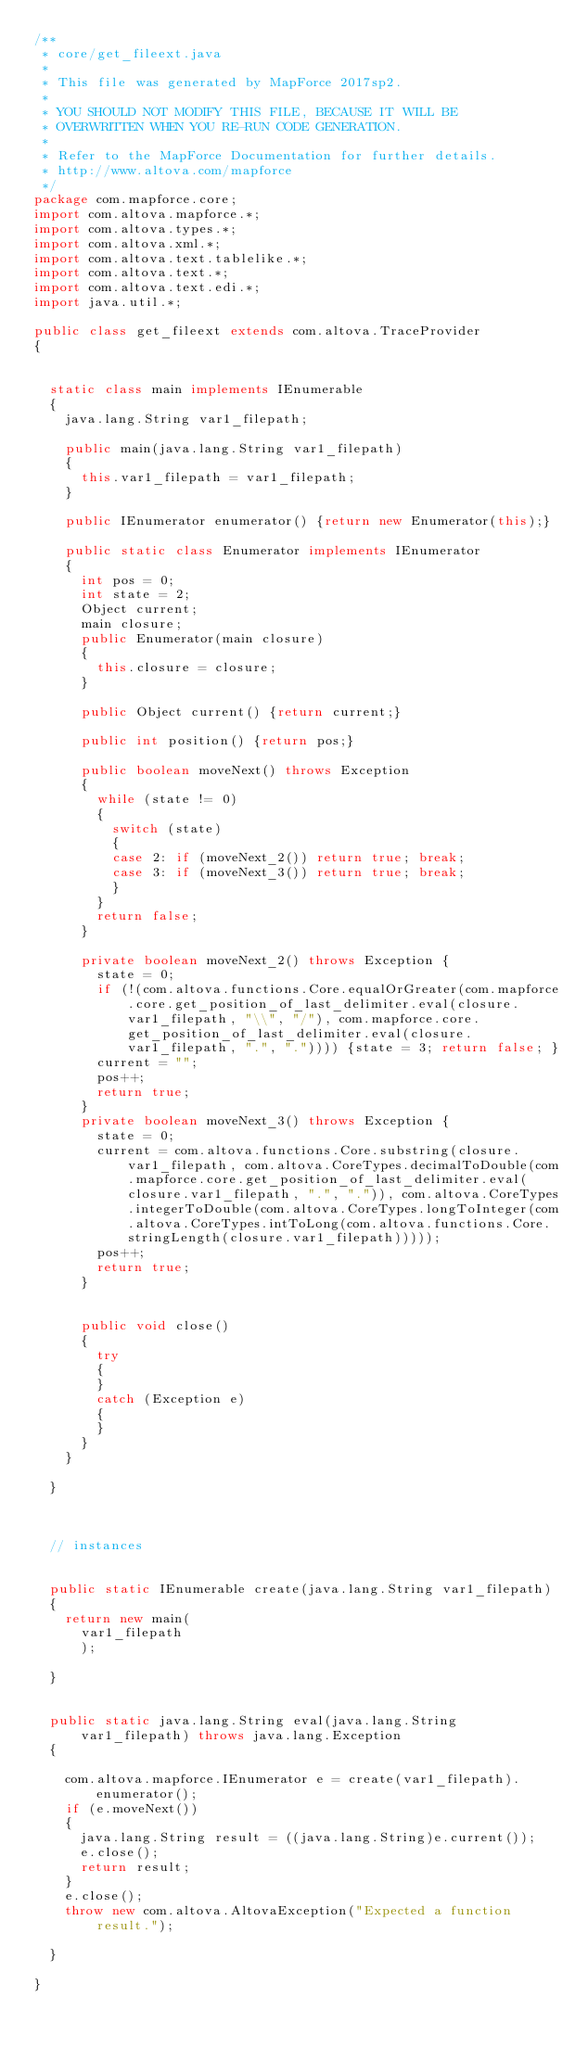Convert code to text. <code><loc_0><loc_0><loc_500><loc_500><_Java_>/**
 * core/get_fileext.java
 *
 * This file was generated by MapForce 2017sp2.
 *
 * YOU SHOULD NOT MODIFY THIS FILE, BECAUSE IT WILL BE
 * OVERWRITTEN WHEN YOU RE-RUN CODE GENERATION.
 *
 * Refer to the MapForce Documentation for further details.
 * http://www.altova.com/mapforce
 */
package com.mapforce.core;
import com.altova.mapforce.*;
import com.altova.types.*;
import com.altova.xml.*;
import com.altova.text.tablelike.*;
import com.altova.text.*;
import com.altova.text.edi.*;
import java.util.*;

public class get_fileext extends com.altova.TraceProvider 
{

	
	static class main implements IEnumerable
	{
		java.lang.String var1_filepath;
	
		public main(java.lang.String var1_filepath)
		{
			this.var1_filepath = var1_filepath;
		}

		public IEnumerator enumerator() {return new Enumerator(this);}
		
		public static class Enumerator implements IEnumerator
		{
			int pos = 0;
			int state = 2;
			Object current;
			main closure;
			public Enumerator(main closure) 
			{
				this.closure = closure;
			}
			
			public Object current() {return current;}
			
			public int position() {return pos;}
			
			public boolean moveNext() throws Exception
			{
				while (state != 0)
				{
					switch (state) 
					{
					case 2:	if (moveNext_2()) return true; break;
					case 3:	if (moveNext_3()) return true; break;
 					}
				}
				return false;
			}

			private boolean moveNext_2() throws Exception {
				state = 0;				
				if (!(com.altova.functions.Core.equalOrGreater(com.mapforce.core.get_position_of_last_delimiter.eval(closure.var1_filepath, "\\", "/"), com.mapforce.core.get_position_of_last_delimiter.eval(closure.var1_filepath, ".", ".")))) {state = 3; return false; }
				current = "";
				pos++;
				return true;
			}
			private boolean moveNext_3() throws Exception {
				state = 0;				
				current = com.altova.functions.Core.substring(closure.var1_filepath, com.altova.CoreTypes.decimalToDouble(com.mapforce.core.get_position_of_last_delimiter.eval(closure.var1_filepath, ".", ".")), com.altova.CoreTypes.integerToDouble(com.altova.CoreTypes.longToInteger(com.altova.CoreTypes.intToLong(com.altova.functions.Core.stringLength(closure.var1_filepath)))));
				pos++;
				return true;
			}

			
			public void close()
			{
				try
				{
				}
				catch (Exception e)
				{
				}
			}
		}
				
	}



	// instances


	public static IEnumerable create(java.lang.String var1_filepath)
	{
		return new main(
			var1_filepath
			);

	}
	

	public static java.lang.String eval(java.lang.String var1_filepath) throws java.lang.Exception
	{

		com.altova.mapforce.IEnumerator e = create(var1_filepath).enumerator();
		if (e.moveNext())
		{
			java.lang.String result = ((java.lang.String)e.current());
			e.close();
			return result;
		}
		e.close();
		throw new com.altova.AltovaException("Expected a function result.");		
	
	}

}
</code> 